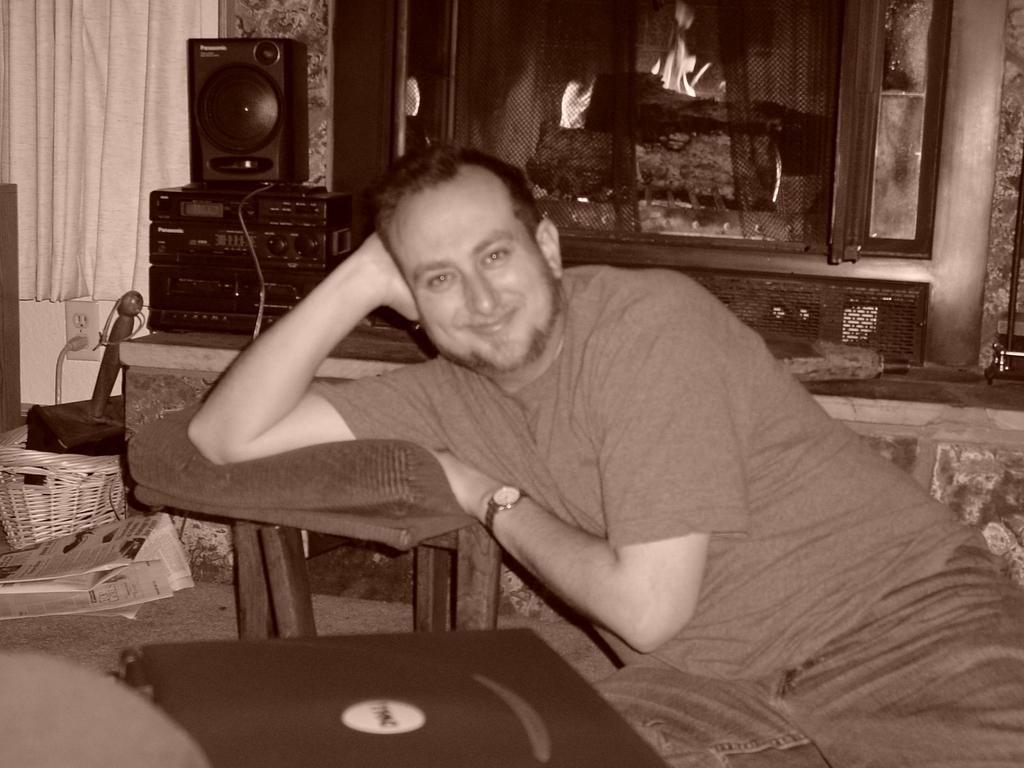How would you summarize this image in a sentence or two? In this image we can see a person is smiling. Beside that person there is a table, on that table there is a pillow. Front of the image we can see a device. Background there is a fireplace, curtains, speaker, devices, basket, newspapers, socket, cable and things.  